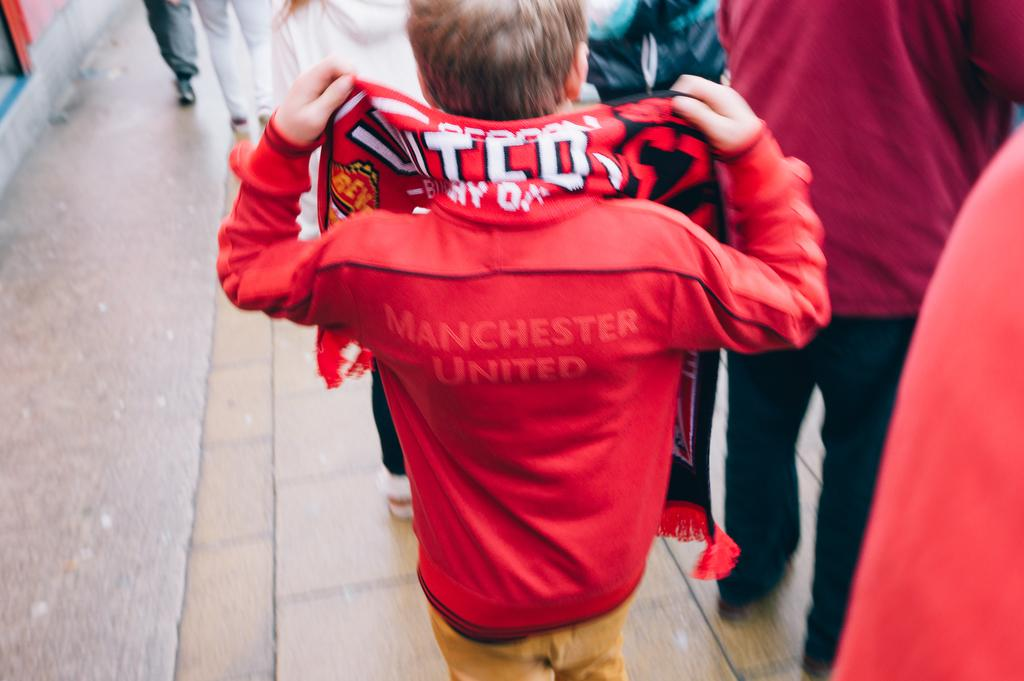<image>
Offer a succinct explanation of the picture presented. Manchester United players and fans wear red jackets. 